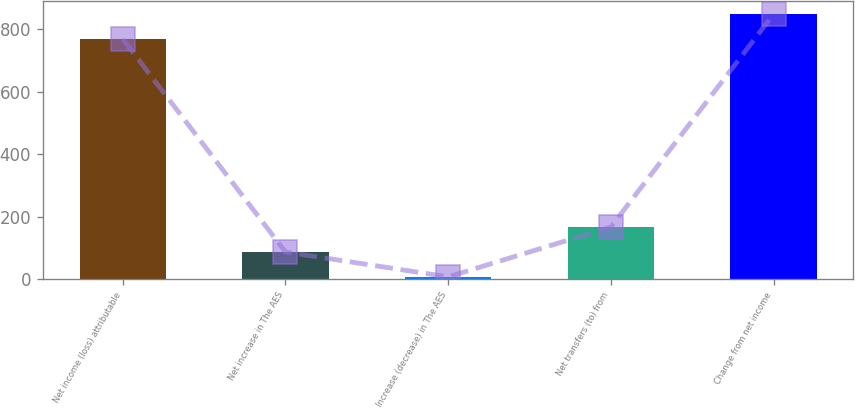Convert chart. <chart><loc_0><loc_0><loc_500><loc_500><bar_chart><fcel>Net income (loss) attributable<fcel>Net increase in The AES<fcel>Increase (decrease) in The AES<fcel>Net transfers (to) from<fcel>Change from net income<nl><fcel>769<fcel>86.8<fcel>7<fcel>166.6<fcel>848.8<nl></chart> 